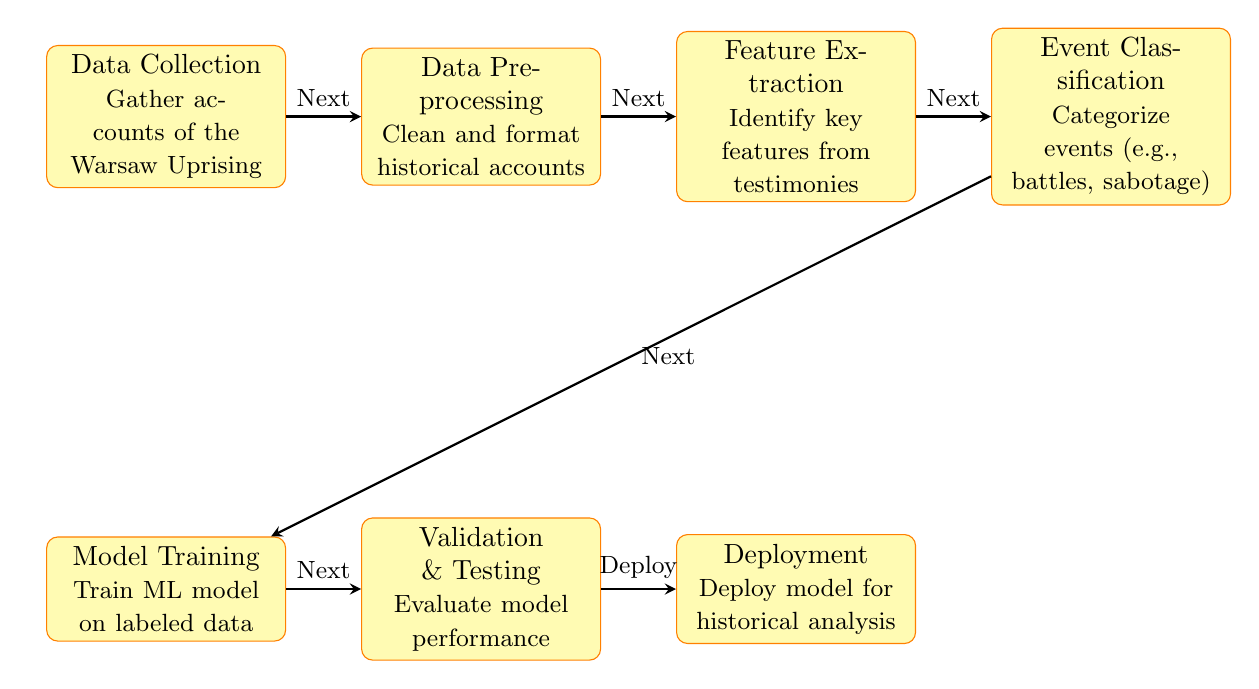What is the first step in the process? The diagram clearly shows that the first node in the flow is "Data Collection." This is where the process begins by gathering accounts of the Warsaw Uprising.
Answer: Data Collection How many processes are illustrated in the diagram? By counting the nodes in the diagram, we see there are a total of seven processes listed from Data Collection to Deployment.
Answer: Seven What kind of events are categorized in the "Event Classification" step? The diagram indicates that the purpose of the "Event Classification" step is to categorize events such as battles and sabotage specifically.
Answer: Battles, sabotage What is the last step before deployment? The diagram shows that the last step before Deployment is "Validation & Testing," indicating that model performance is evaluated just before the final deployment.
Answer: Validation & Testing Which two processes are directly interconnected? The diagram shows direct arrows connecting various processes; for instance, there's a direct connection between "Feature Extraction" and "Event Classification," indicating they are sequentially related.
Answer: Feature Extraction and Event Classification In what step is the model trained? According to the layout of the diagram, "Model Training" is the step that focuses on training the machine learning model using labeled data.
Answer: Model Training What step follows "Data Preprocessing"? Following the "Data Preprocessing" node, the next step indicated in the diagram is "Feature Extraction," which is part of the sequential process outlined.
Answer: Feature Extraction Which step evaluates the performance of the model? The diagram identifies the "Validation & Testing" step as the one specifically meant for evaluating the performance of the model after it has been trained.
Answer: Validation & Testing What is the purpose of "Feature Extraction"? The "Feature Extraction" process is defined as identifying key features from testimonies, which is crucial for further classification.
Answer: Identify key features from testimonies 